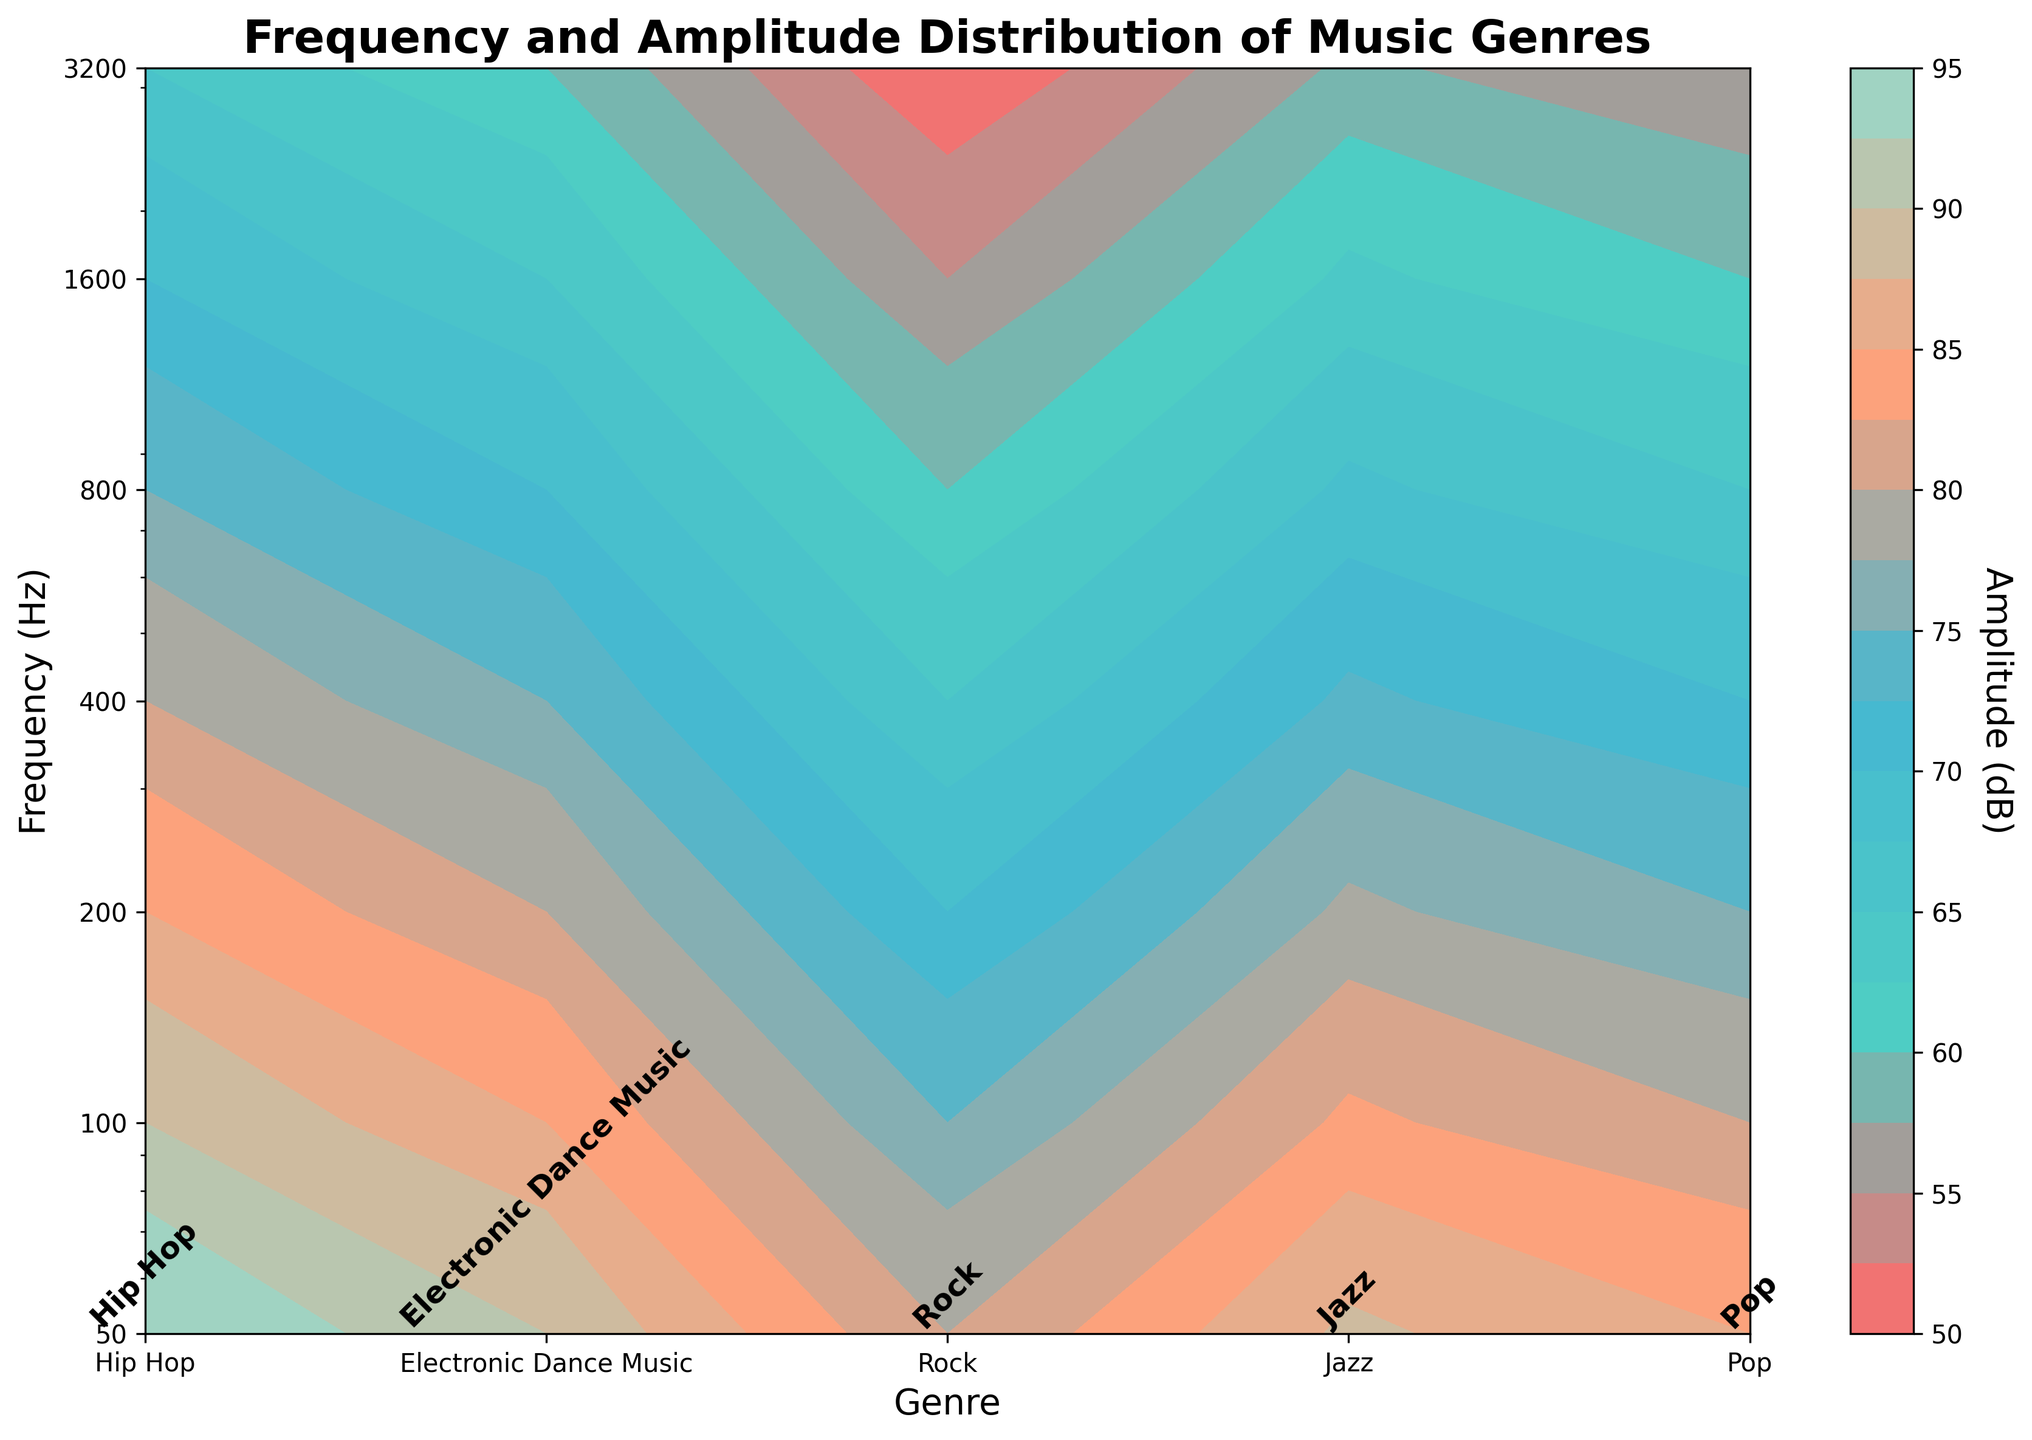What is the title of the plot? Look at the top of the plot where the title is usually placed. The title is displayed as 'Frequency and Amplitude Distribution of Music Genres'.
Answer: Frequency and Amplitude Distribution of Music Genres How many different music genres are displayed in the plot? Count the number of unique labels along the x-axis of the plot, corresponding to the different music genres.
Answer: 5 At what frequency does Hip Hop have an amplitude of 75 dB? Find the contour line for the Hip Hop genre that corresponds to 75 dB and check its intersection with the frequency axis. The frequency at this intersection is 400 Hz.
Answer: 400 Hz Which genre shows the highest amplitude at a frequency of 100 Hz? Compare the amplitude values for all genres at 100 Hz and identify the maximum value. The highest amplitude at 100 Hz is found in the Electronic Dance Music genre.
Answer: Electronic Dance Music Do any two genres have the same amplitude at 200 Hz? Check the contour lines for all genres at 200 Hz and compare their amplitude values. Both Hip Hop and Electronic Dance Music have an amplitude of 85 dB at 200 Hz.
Answer: Yes, Hip Hop and Electronic Dance Music Which genre shows the steepest decline in amplitude as the frequency increases up to 3200 Hz? Examine the change in amplitude for each genre as frequency increases and identify the one with the largest decrease. Jazz shows a very steep decline from 80 dB at 50 Hz to 50 dB at 3200 Hz.
Answer: Jazz Between Rock and Pop, which genre has a higher amplitude at a frequency of 800 Hz? Compare the two amplitude values for Rock and Pop at 800 Hz. Rock has an amplitude of 65 dB, whereas Pop has 68 dB.
Answer: Pop What is the pattern of amplitude changes for Electronic Dance Music from 50 Hz to 3200 Hz? Trace the contour for the Electronic Dance Music genre and note the amplitude values at each frequency. The amplitude steadily decreases: 95 dB at 50 Hz, 90 dB at 100 Hz, 85 dB at 200 Hz, 80 dB at 400 Hz, 75 dB at 800 Hz, 70 dB at 1600 Hz, and 65 dB at 3200 Hz.
Answer: Steadily decreases Which genre has the smallest range of amplitude values across all frequencies? Calculate the range (difference between maximum and minimum amplitude) for each genre, and identify the one with the smallest range. Jazz ranges from 80 dB to 50 dB across all frequencies, which is the narrowest range.
Answer: Jazz 